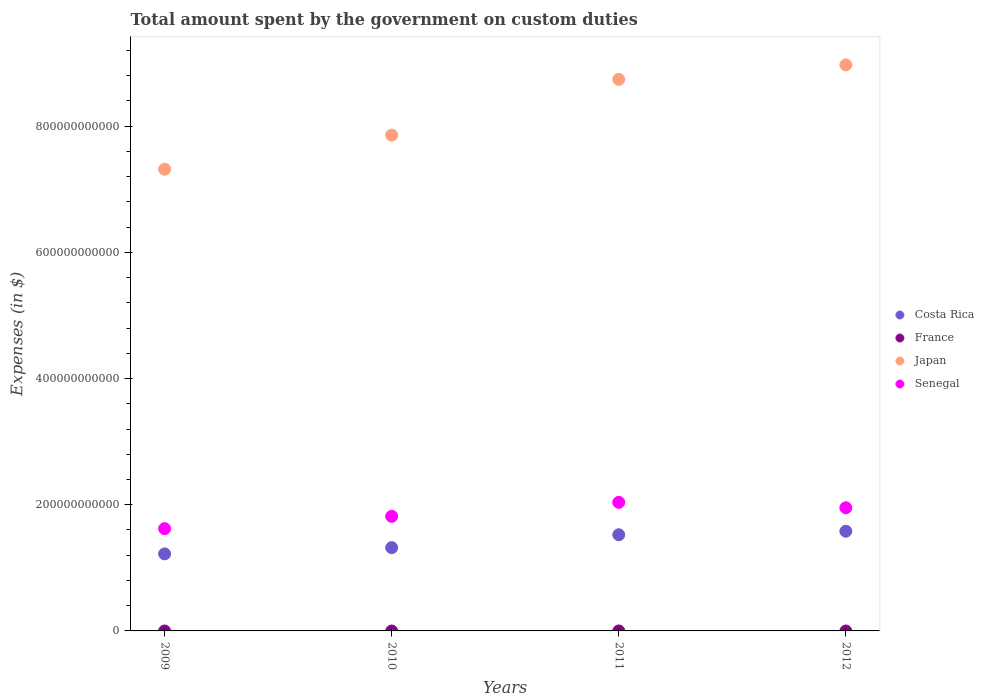Is the number of dotlines equal to the number of legend labels?
Your response must be concise. No. What is the amount spent on custom duties by the government in Senegal in 2012?
Your answer should be compact. 1.95e+11. Across all years, what is the maximum amount spent on custom duties by the government in Costa Rica?
Ensure brevity in your answer.  1.58e+11. Across all years, what is the minimum amount spent on custom duties by the government in Senegal?
Make the answer very short. 1.62e+11. What is the total amount spent on custom duties by the government in Japan in the graph?
Provide a short and direct response. 3.29e+12. What is the difference between the amount spent on custom duties by the government in Senegal in 2009 and that in 2011?
Your response must be concise. -4.17e+1. What is the difference between the amount spent on custom duties by the government in Japan in 2012 and the amount spent on custom duties by the government in Senegal in 2009?
Offer a terse response. 7.35e+11. What is the average amount spent on custom duties by the government in Costa Rica per year?
Provide a succinct answer. 1.41e+11. In the year 2009, what is the difference between the amount spent on custom duties by the government in Costa Rica and amount spent on custom duties by the government in Japan?
Your response must be concise. -6.10e+11. What is the ratio of the amount spent on custom duties by the government in Senegal in 2009 to that in 2012?
Make the answer very short. 0.83. Is the amount spent on custom duties by the government in Costa Rica in 2009 less than that in 2011?
Offer a very short reply. Yes. Is the difference between the amount spent on custom duties by the government in Costa Rica in 2010 and 2011 greater than the difference between the amount spent on custom duties by the government in Japan in 2010 and 2011?
Your answer should be very brief. Yes. What is the difference between the highest and the second highest amount spent on custom duties by the government in Costa Rica?
Offer a very short reply. 5.59e+09. What is the difference between the highest and the lowest amount spent on custom duties by the government in Costa Rica?
Your answer should be very brief. 3.59e+1. Is it the case that in every year, the sum of the amount spent on custom duties by the government in Costa Rica and amount spent on custom duties by the government in Japan  is greater than the amount spent on custom duties by the government in France?
Make the answer very short. Yes. Does the amount spent on custom duties by the government in Japan monotonically increase over the years?
Your answer should be compact. Yes. Is the amount spent on custom duties by the government in Costa Rica strictly greater than the amount spent on custom duties by the government in Senegal over the years?
Offer a terse response. No. Is the amount spent on custom duties by the government in Japan strictly less than the amount spent on custom duties by the government in Senegal over the years?
Your answer should be very brief. No. How many years are there in the graph?
Keep it short and to the point. 4. What is the difference between two consecutive major ticks on the Y-axis?
Offer a very short reply. 2.00e+11. Does the graph contain any zero values?
Offer a terse response. Yes. How many legend labels are there?
Your response must be concise. 4. What is the title of the graph?
Offer a terse response. Total amount spent by the government on custom duties. Does "Moldova" appear as one of the legend labels in the graph?
Offer a terse response. No. What is the label or title of the Y-axis?
Your answer should be very brief. Expenses (in $). What is the Expenses (in $) in Costa Rica in 2009?
Make the answer very short. 1.22e+11. What is the Expenses (in $) of Japan in 2009?
Provide a short and direct response. 7.32e+11. What is the Expenses (in $) of Senegal in 2009?
Make the answer very short. 1.62e+11. What is the Expenses (in $) of Costa Rica in 2010?
Your answer should be compact. 1.32e+11. What is the Expenses (in $) of Japan in 2010?
Your response must be concise. 7.86e+11. What is the Expenses (in $) in Senegal in 2010?
Make the answer very short. 1.82e+11. What is the Expenses (in $) in Costa Rica in 2011?
Your response must be concise. 1.52e+11. What is the Expenses (in $) in Japan in 2011?
Your answer should be very brief. 8.74e+11. What is the Expenses (in $) in Senegal in 2011?
Offer a terse response. 2.04e+11. What is the Expenses (in $) of Costa Rica in 2012?
Your response must be concise. 1.58e+11. What is the Expenses (in $) of France in 2012?
Keep it short and to the point. 0. What is the Expenses (in $) in Japan in 2012?
Ensure brevity in your answer.  8.97e+11. What is the Expenses (in $) in Senegal in 2012?
Provide a succinct answer. 1.95e+11. Across all years, what is the maximum Expenses (in $) of Costa Rica?
Your answer should be very brief. 1.58e+11. Across all years, what is the maximum Expenses (in $) of Japan?
Your answer should be very brief. 8.97e+11. Across all years, what is the maximum Expenses (in $) of Senegal?
Provide a succinct answer. 2.04e+11. Across all years, what is the minimum Expenses (in $) in Costa Rica?
Keep it short and to the point. 1.22e+11. Across all years, what is the minimum Expenses (in $) of Japan?
Your answer should be very brief. 7.32e+11. Across all years, what is the minimum Expenses (in $) of Senegal?
Make the answer very short. 1.62e+11. What is the total Expenses (in $) in Costa Rica in the graph?
Your answer should be compact. 5.65e+11. What is the total Expenses (in $) in France in the graph?
Offer a terse response. 0. What is the total Expenses (in $) of Japan in the graph?
Make the answer very short. 3.29e+12. What is the total Expenses (in $) of Senegal in the graph?
Your answer should be compact. 7.43e+11. What is the difference between the Expenses (in $) in Costa Rica in 2009 and that in 2010?
Your response must be concise. -9.89e+09. What is the difference between the Expenses (in $) of Japan in 2009 and that in 2010?
Provide a succinct answer. -5.40e+1. What is the difference between the Expenses (in $) of Senegal in 2009 and that in 2010?
Your answer should be very brief. -1.95e+1. What is the difference between the Expenses (in $) in Costa Rica in 2009 and that in 2011?
Keep it short and to the point. -3.03e+1. What is the difference between the Expenses (in $) in Japan in 2009 and that in 2011?
Your response must be concise. -1.42e+11. What is the difference between the Expenses (in $) of Senegal in 2009 and that in 2011?
Provide a short and direct response. -4.17e+1. What is the difference between the Expenses (in $) of Costa Rica in 2009 and that in 2012?
Your answer should be very brief. -3.59e+1. What is the difference between the Expenses (in $) of Japan in 2009 and that in 2012?
Ensure brevity in your answer.  -1.65e+11. What is the difference between the Expenses (in $) in Senegal in 2009 and that in 2012?
Ensure brevity in your answer.  -3.31e+1. What is the difference between the Expenses (in $) in Costa Rica in 2010 and that in 2011?
Ensure brevity in your answer.  -2.04e+1. What is the difference between the Expenses (in $) of Japan in 2010 and that in 2011?
Your answer should be very brief. -8.83e+1. What is the difference between the Expenses (in $) of Senegal in 2010 and that in 2011?
Ensure brevity in your answer.  -2.22e+1. What is the difference between the Expenses (in $) of Costa Rica in 2010 and that in 2012?
Your response must be concise. -2.60e+1. What is the difference between the Expenses (in $) in Japan in 2010 and that in 2012?
Your answer should be very brief. -1.11e+11. What is the difference between the Expenses (in $) of Senegal in 2010 and that in 2012?
Give a very brief answer. -1.36e+1. What is the difference between the Expenses (in $) in Costa Rica in 2011 and that in 2012?
Your response must be concise. -5.59e+09. What is the difference between the Expenses (in $) in Japan in 2011 and that in 2012?
Offer a very short reply. -2.30e+1. What is the difference between the Expenses (in $) in Senegal in 2011 and that in 2012?
Your response must be concise. 8.60e+09. What is the difference between the Expenses (in $) of Costa Rica in 2009 and the Expenses (in $) of Japan in 2010?
Offer a terse response. -6.64e+11. What is the difference between the Expenses (in $) in Costa Rica in 2009 and the Expenses (in $) in Senegal in 2010?
Give a very brief answer. -5.95e+1. What is the difference between the Expenses (in $) of Japan in 2009 and the Expenses (in $) of Senegal in 2010?
Provide a succinct answer. 5.50e+11. What is the difference between the Expenses (in $) in Costa Rica in 2009 and the Expenses (in $) in Japan in 2011?
Make the answer very short. -7.52e+11. What is the difference between the Expenses (in $) in Costa Rica in 2009 and the Expenses (in $) in Senegal in 2011?
Your answer should be compact. -8.17e+1. What is the difference between the Expenses (in $) of Japan in 2009 and the Expenses (in $) of Senegal in 2011?
Your answer should be compact. 5.28e+11. What is the difference between the Expenses (in $) in Costa Rica in 2009 and the Expenses (in $) in Japan in 2012?
Ensure brevity in your answer.  -7.75e+11. What is the difference between the Expenses (in $) in Costa Rica in 2009 and the Expenses (in $) in Senegal in 2012?
Give a very brief answer. -7.31e+1. What is the difference between the Expenses (in $) in Japan in 2009 and the Expenses (in $) in Senegal in 2012?
Make the answer very short. 5.37e+11. What is the difference between the Expenses (in $) in Costa Rica in 2010 and the Expenses (in $) in Japan in 2011?
Your response must be concise. -7.42e+11. What is the difference between the Expenses (in $) in Costa Rica in 2010 and the Expenses (in $) in Senegal in 2011?
Offer a very short reply. -7.18e+1. What is the difference between the Expenses (in $) in Japan in 2010 and the Expenses (in $) in Senegal in 2011?
Keep it short and to the point. 5.82e+11. What is the difference between the Expenses (in $) of Costa Rica in 2010 and the Expenses (in $) of Japan in 2012?
Your answer should be compact. -7.65e+11. What is the difference between the Expenses (in $) of Costa Rica in 2010 and the Expenses (in $) of Senegal in 2012?
Offer a terse response. -6.32e+1. What is the difference between the Expenses (in $) of Japan in 2010 and the Expenses (in $) of Senegal in 2012?
Your response must be concise. 5.91e+11. What is the difference between the Expenses (in $) of Costa Rica in 2011 and the Expenses (in $) of Japan in 2012?
Ensure brevity in your answer.  -7.45e+11. What is the difference between the Expenses (in $) in Costa Rica in 2011 and the Expenses (in $) in Senegal in 2012?
Provide a short and direct response. -4.28e+1. What is the difference between the Expenses (in $) of Japan in 2011 and the Expenses (in $) of Senegal in 2012?
Make the answer very short. 6.79e+11. What is the average Expenses (in $) in Costa Rica per year?
Your answer should be compact. 1.41e+11. What is the average Expenses (in $) of France per year?
Provide a succinct answer. 0. What is the average Expenses (in $) in Japan per year?
Your response must be concise. 8.22e+11. What is the average Expenses (in $) in Senegal per year?
Keep it short and to the point. 1.86e+11. In the year 2009, what is the difference between the Expenses (in $) of Costa Rica and Expenses (in $) of Japan?
Make the answer very short. -6.10e+11. In the year 2009, what is the difference between the Expenses (in $) in Costa Rica and Expenses (in $) in Senegal?
Your response must be concise. -4.00e+1. In the year 2009, what is the difference between the Expenses (in $) of Japan and Expenses (in $) of Senegal?
Give a very brief answer. 5.70e+11. In the year 2010, what is the difference between the Expenses (in $) of Costa Rica and Expenses (in $) of Japan?
Provide a short and direct response. -6.54e+11. In the year 2010, what is the difference between the Expenses (in $) of Costa Rica and Expenses (in $) of Senegal?
Offer a very short reply. -4.96e+1. In the year 2010, what is the difference between the Expenses (in $) in Japan and Expenses (in $) in Senegal?
Provide a short and direct response. 6.04e+11. In the year 2011, what is the difference between the Expenses (in $) in Costa Rica and Expenses (in $) in Japan?
Provide a short and direct response. -7.22e+11. In the year 2011, what is the difference between the Expenses (in $) in Costa Rica and Expenses (in $) in Senegal?
Your response must be concise. -5.14e+1. In the year 2011, what is the difference between the Expenses (in $) of Japan and Expenses (in $) of Senegal?
Your answer should be compact. 6.70e+11. In the year 2012, what is the difference between the Expenses (in $) of Costa Rica and Expenses (in $) of Japan?
Make the answer very short. -7.39e+11. In the year 2012, what is the difference between the Expenses (in $) of Costa Rica and Expenses (in $) of Senegal?
Offer a terse response. -3.72e+1. In the year 2012, what is the difference between the Expenses (in $) of Japan and Expenses (in $) of Senegal?
Provide a short and direct response. 7.02e+11. What is the ratio of the Expenses (in $) of Costa Rica in 2009 to that in 2010?
Provide a succinct answer. 0.93. What is the ratio of the Expenses (in $) in Japan in 2009 to that in 2010?
Your answer should be compact. 0.93. What is the ratio of the Expenses (in $) of Senegal in 2009 to that in 2010?
Offer a very short reply. 0.89. What is the ratio of the Expenses (in $) in Costa Rica in 2009 to that in 2011?
Your answer should be compact. 0.8. What is the ratio of the Expenses (in $) in Japan in 2009 to that in 2011?
Make the answer very short. 0.84. What is the ratio of the Expenses (in $) of Senegal in 2009 to that in 2011?
Provide a succinct answer. 0.8. What is the ratio of the Expenses (in $) of Costa Rica in 2009 to that in 2012?
Provide a short and direct response. 0.77. What is the ratio of the Expenses (in $) of Japan in 2009 to that in 2012?
Keep it short and to the point. 0.82. What is the ratio of the Expenses (in $) in Senegal in 2009 to that in 2012?
Your answer should be compact. 0.83. What is the ratio of the Expenses (in $) in Costa Rica in 2010 to that in 2011?
Keep it short and to the point. 0.87. What is the ratio of the Expenses (in $) in Japan in 2010 to that in 2011?
Offer a terse response. 0.9. What is the ratio of the Expenses (in $) in Senegal in 2010 to that in 2011?
Provide a succinct answer. 0.89. What is the ratio of the Expenses (in $) of Costa Rica in 2010 to that in 2012?
Make the answer very short. 0.84. What is the ratio of the Expenses (in $) of Japan in 2010 to that in 2012?
Keep it short and to the point. 0.88. What is the ratio of the Expenses (in $) in Senegal in 2010 to that in 2012?
Provide a short and direct response. 0.93. What is the ratio of the Expenses (in $) in Costa Rica in 2011 to that in 2012?
Make the answer very short. 0.96. What is the ratio of the Expenses (in $) of Japan in 2011 to that in 2012?
Provide a short and direct response. 0.97. What is the ratio of the Expenses (in $) in Senegal in 2011 to that in 2012?
Your answer should be very brief. 1.04. What is the difference between the highest and the second highest Expenses (in $) in Costa Rica?
Make the answer very short. 5.59e+09. What is the difference between the highest and the second highest Expenses (in $) of Japan?
Provide a short and direct response. 2.30e+1. What is the difference between the highest and the second highest Expenses (in $) in Senegal?
Your answer should be compact. 8.60e+09. What is the difference between the highest and the lowest Expenses (in $) of Costa Rica?
Provide a succinct answer. 3.59e+1. What is the difference between the highest and the lowest Expenses (in $) of Japan?
Offer a terse response. 1.65e+11. What is the difference between the highest and the lowest Expenses (in $) of Senegal?
Your response must be concise. 4.17e+1. 